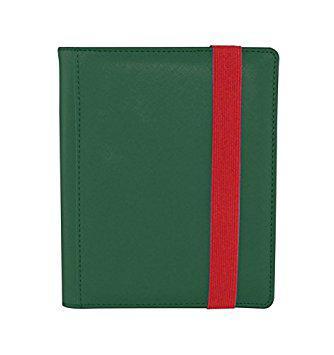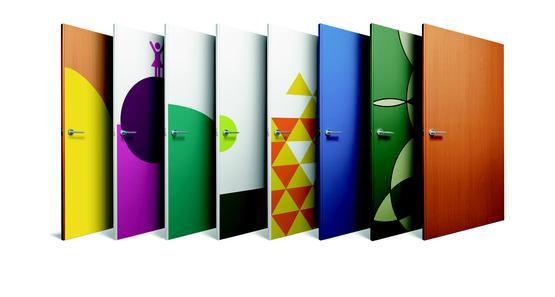The first image is the image on the left, the second image is the image on the right. Analyze the images presented: Is the assertion "Only one folder is on the left image." valid? Answer yes or no. Yes. 